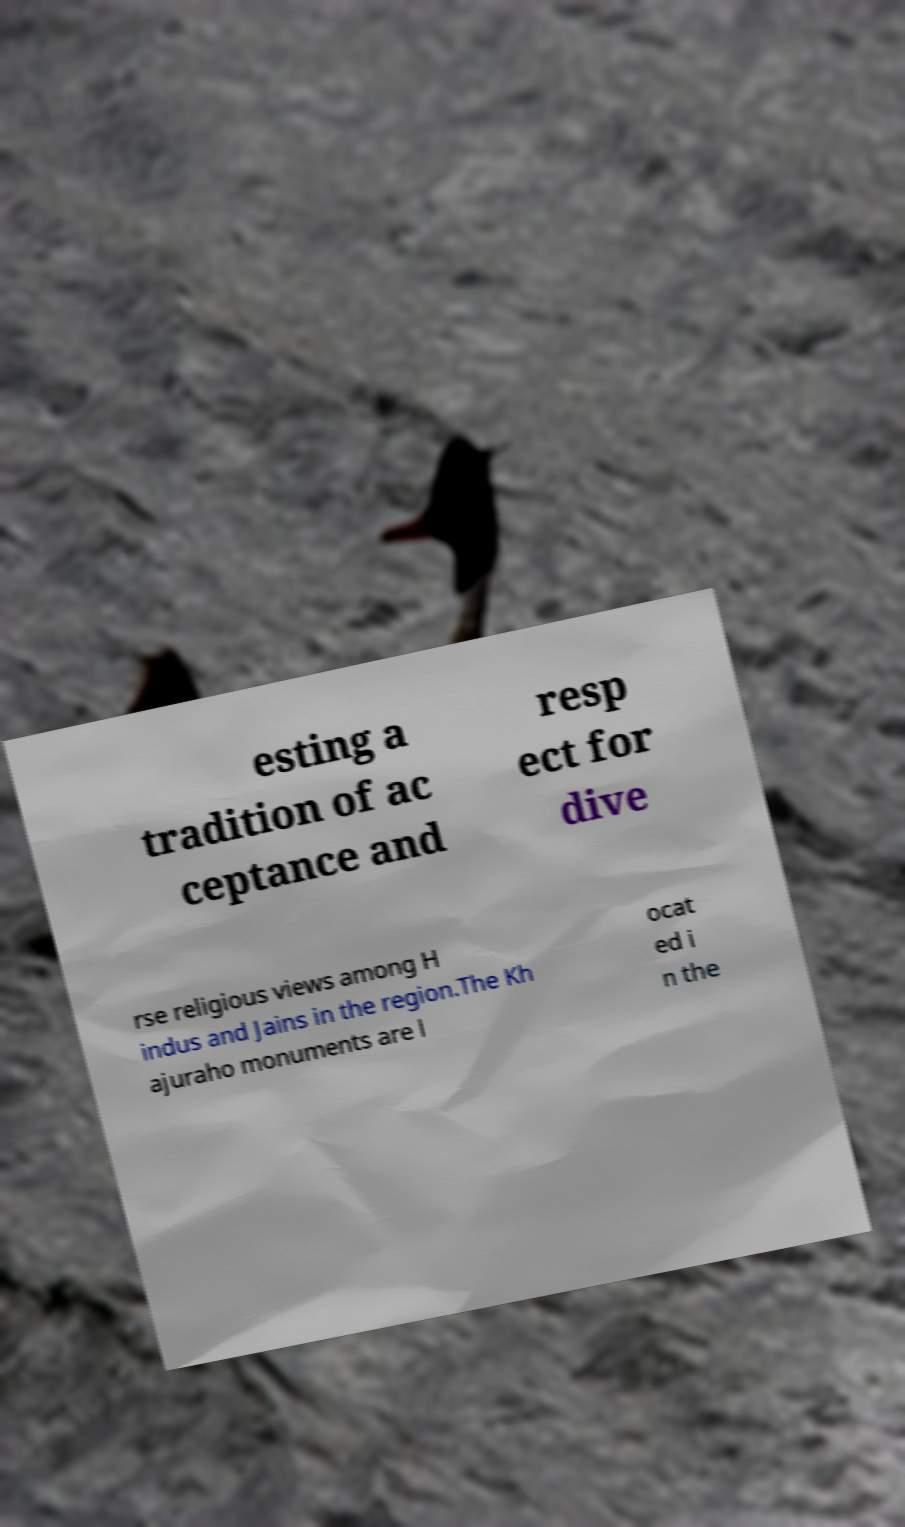Could you assist in decoding the text presented in this image and type it out clearly? esting a tradition of ac ceptance and resp ect for dive rse religious views among H indus and Jains in the region.The Kh ajuraho monuments are l ocat ed i n the 